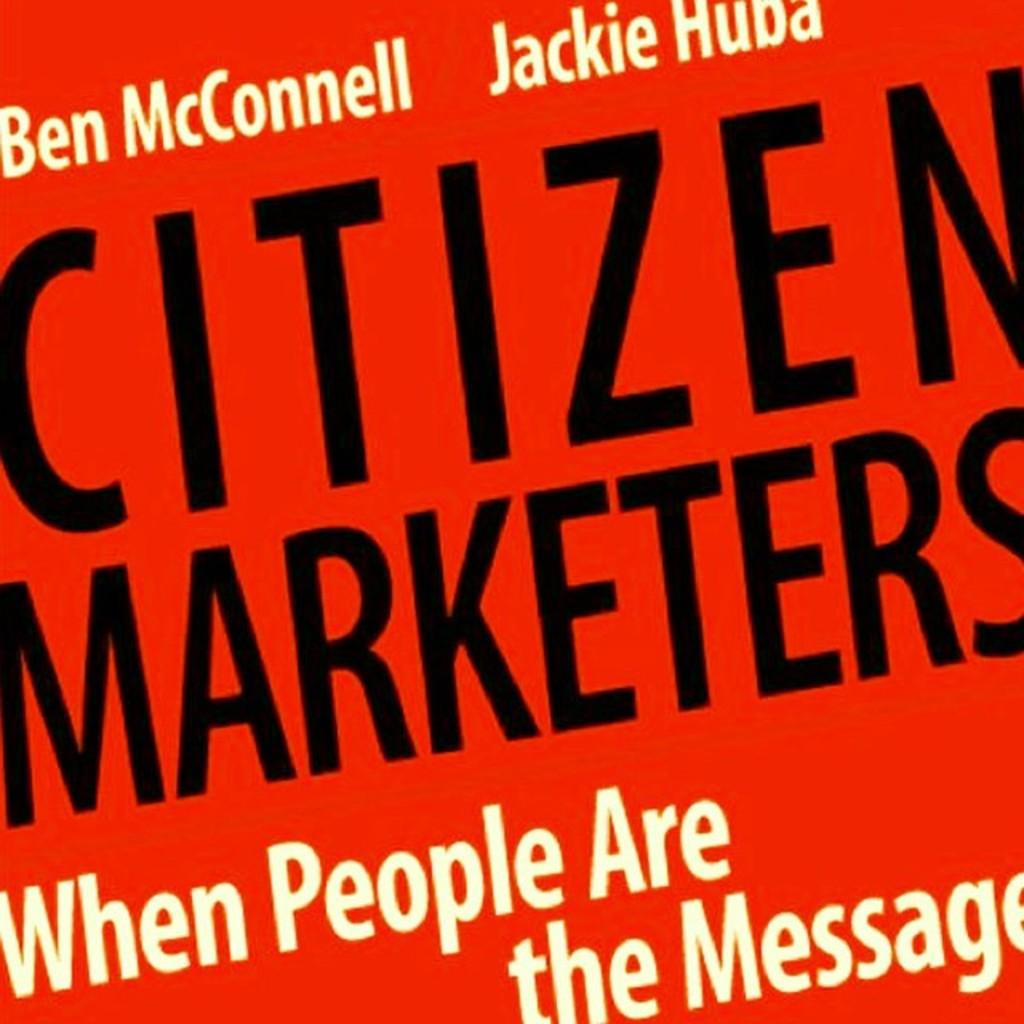<image>
Offer a succinct explanation of the picture presented. Ben McConnell and Jackie Huba wrote Citizen Marketers. 